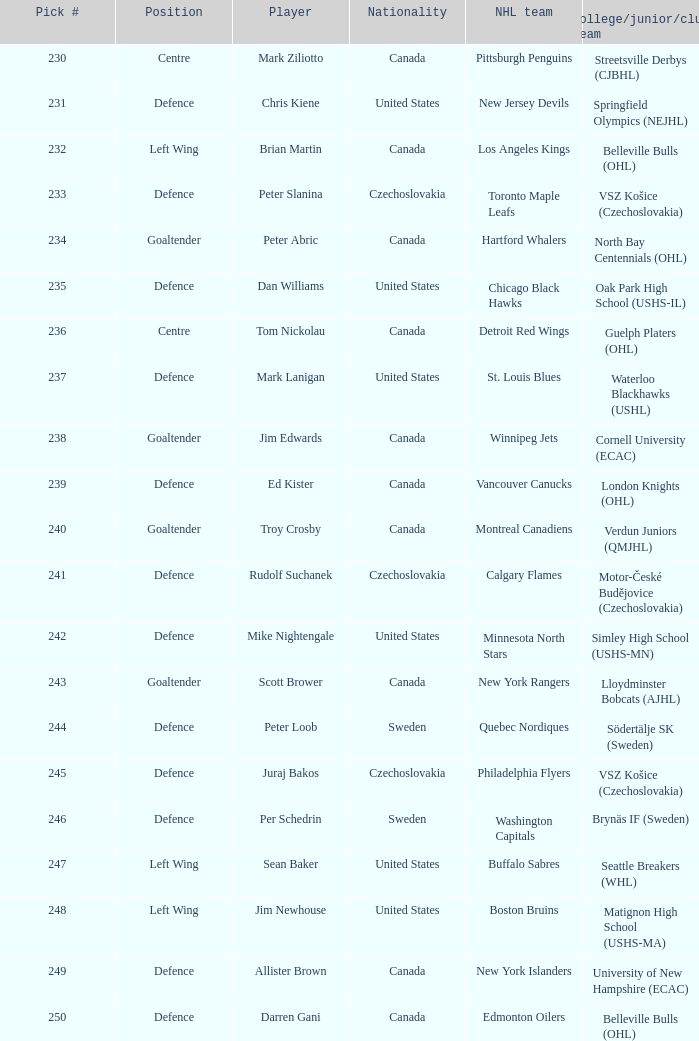List the players for team brynäs if (sweden). Per Schedrin. 